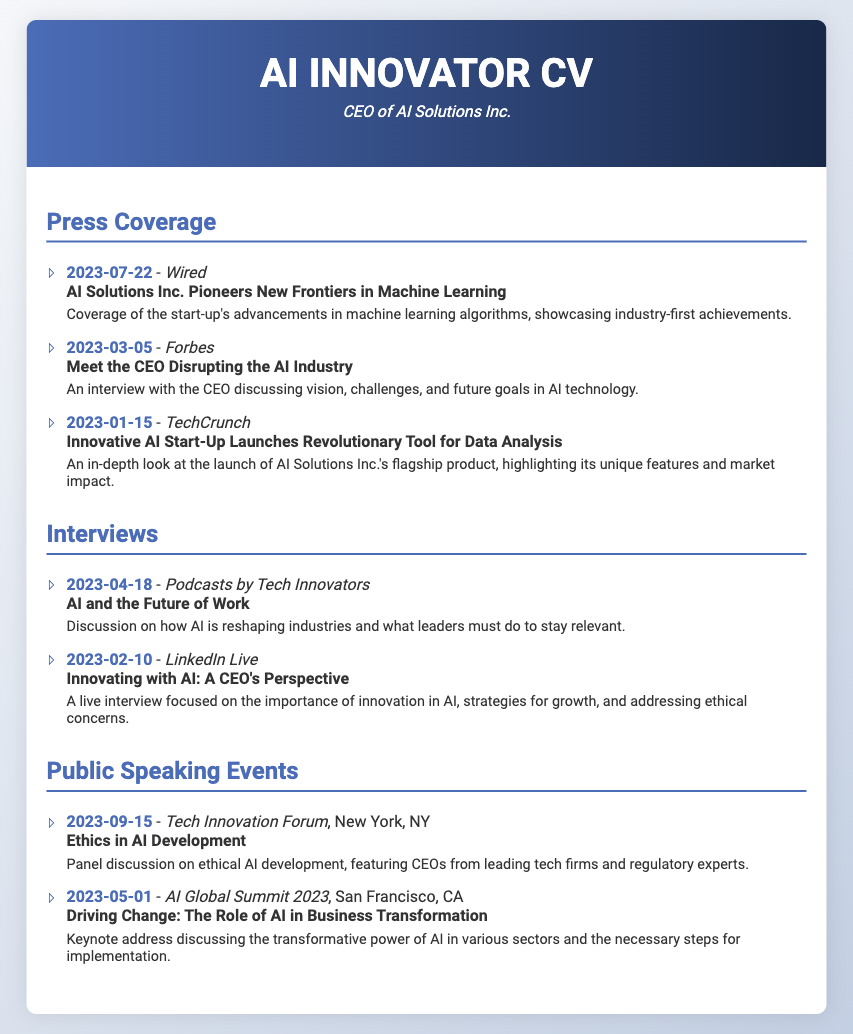what is the date of the Wired article? The date of the Wired article is listed in the document under Press Coverage.
Answer: 2023-07-22 who was interviewed by Forbes? The document highlights an interview with the CEO in the Forbes article.
Answer: the CEO what topic was discussed in the keynote address at AI Global Summit 2023? The document specifies the topic of the keynote address at AI Global Summit 2023 under Public Speaking Events.
Answer: Driving Change: The Role of AI in Business Transformation how many interviews are listed in the document? The document lists two interviews under the Interviews section.
Answer: 2 which publication featured an article about the launch of a revolutionary tool for data analysis? The document indicates that TechCrunch covered the launch of the tool in their article.
Answer: TechCrunch what was the focus of the panel discussion at the Tech Innovation Forum? The focus of the panel discussion at the Tech Innovation Forum is mentioned in the Public Speaking Events section of the document.
Answer: Ethics in AI Development when did the in-depth look at AI Solutions Inc.'s flagship product take place? The date of the in-depth look at the flagship product is provided under Press Coverage.
Answer: 2023-01-15 which platform hosted a discussion about AI reshaping industries? The document states the discussion about AI reshaping industries was hosted on Podcasts by Tech Innovators.
Answer: Podcasts by Tech Innovators how many press coverage entries are provided in total? The document details three entries in the Press Coverage section.
Answer: 3 